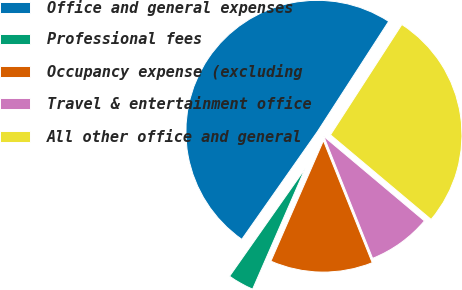<chart> <loc_0><loc_0><loc_500><loc_500><pie_chart><fcel>Office and general expenses<fcel>Professional fees<fcel>Occupancy expense (excluding<fcel>Travel & entertainment office<fcel>All other office and general<nl><fcel>49.39%<fcel>3.2%<fcel>12.6%<fcel>7.82%<fcel>26.99%<nl></chart> 